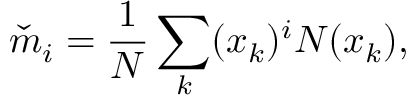Convert formula to latex. <formula><loc_0><loc_0><loc_500><loc_500>\check { m } _ { i } = \frac { 1 } { N } \sum _ { k } ( x _ { k } ) ^ { i } N ( x _ { k } ) ,</formula> 